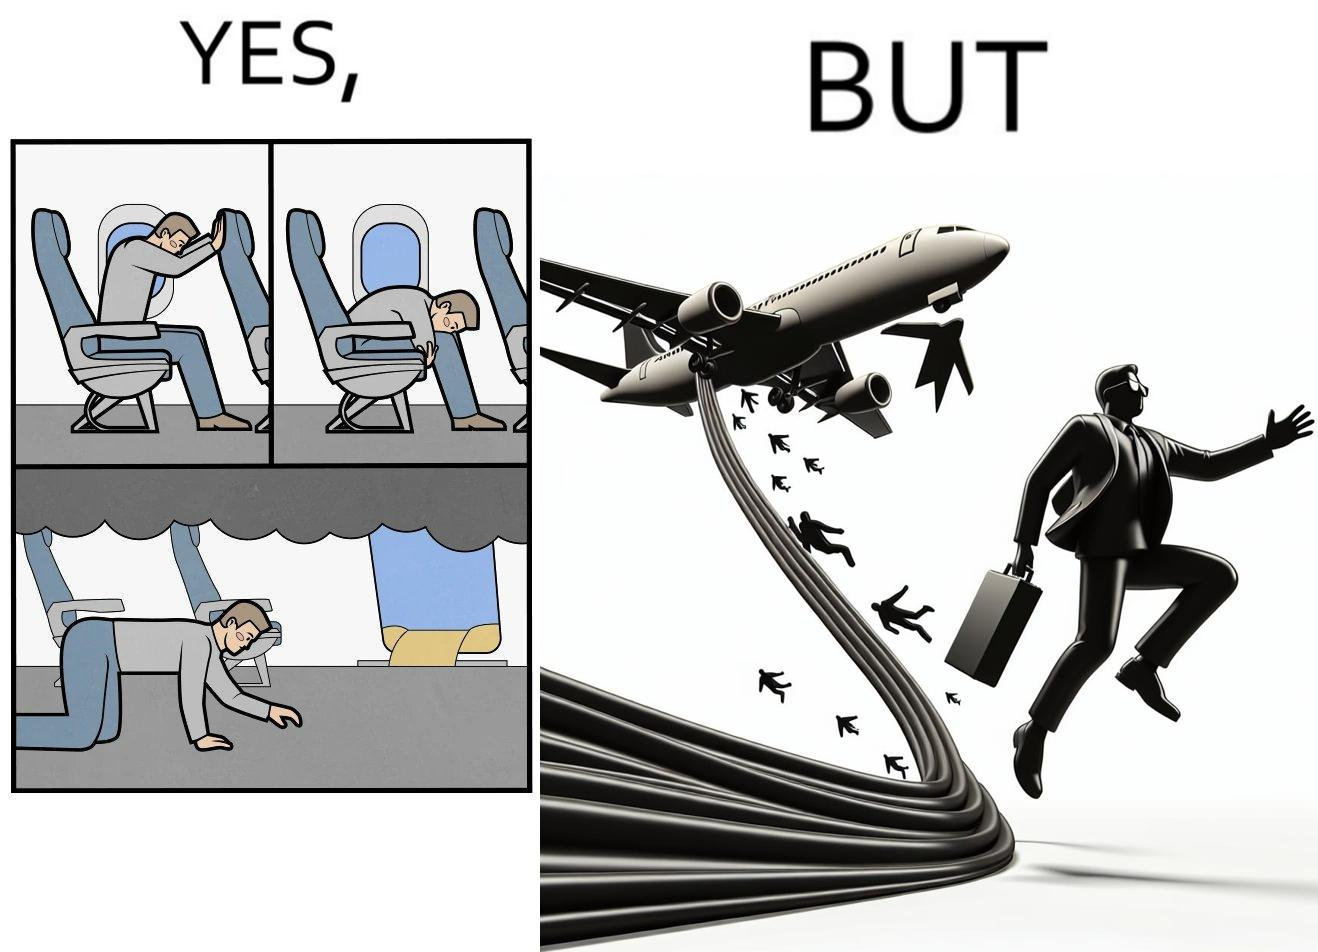What is the satirical meaning behind this image? These images are funny since it shows how we are taught emergency procedures to follow in case of an accident while in an airplane but how none of them work if the plane is still in air 